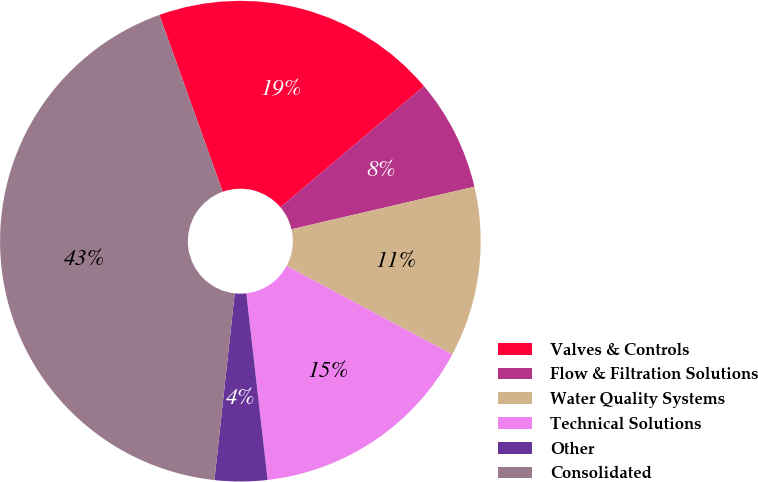<chart> <loc_0><loc_0><loc_500><loc_500><pie_chart><fcel>Valves & Controls<fcel>Flow & Filtration Solutions<fcel>Water Quality Systems<fcel>Technical Solutions<fcel>Other<fcel>Consolidated<nl><fcel>19.31%<fcel>7.52%<fcel>11.45%<fcel>15.38%<fcel>3.53%<fcel>42.81%<nl></chart> 